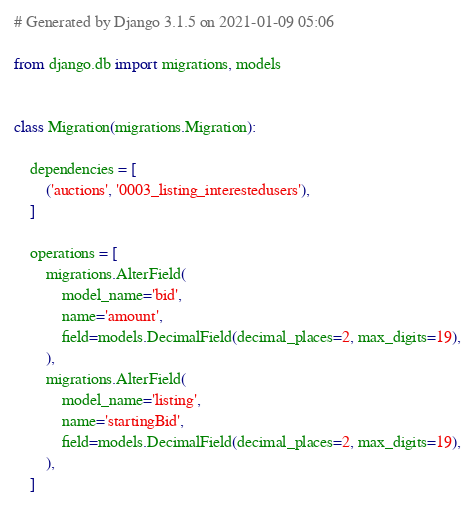Convert code to text. <code><loc_0><loc_0><loc_500><loc_500><_Python_># Generated by Django 3.1.5 on 2021-01-09 05:06

from django.db import migrations, models


class Migration(migrations.Migration):

    dependencies = [
        ('auctions', '0003_listing_interestedusers'),
    ]

    operations = [
        migrations.AlterField(
            model_name='bid',
            name='amount',
            field=models.DecimalField(decimal_places=2, max_digits=19),
        ),
        migrations.AlterField(
            model_name='listing',
            name='startingBid',
            field=models.DecimalField(decimal_places=2, max_digits=19),
        ),
    ]
</code> 